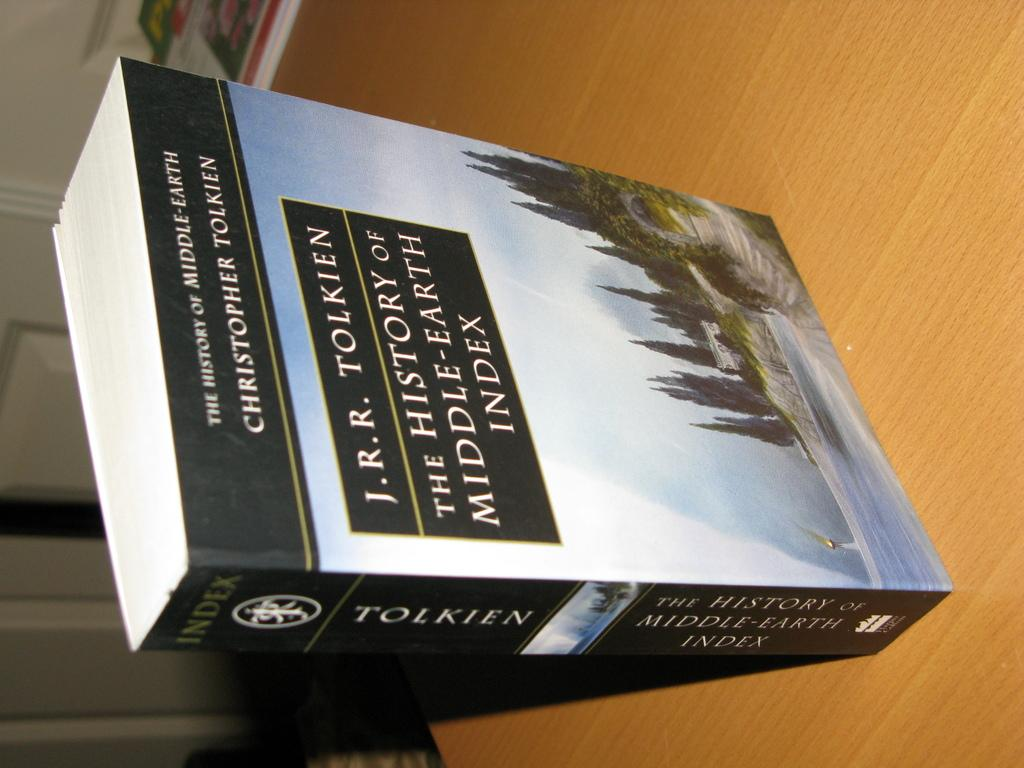Provide a one-sentence caption for the provided image. J.R.R. Tolkien's "The History of Middle-Earth Index" is available in paperback. 